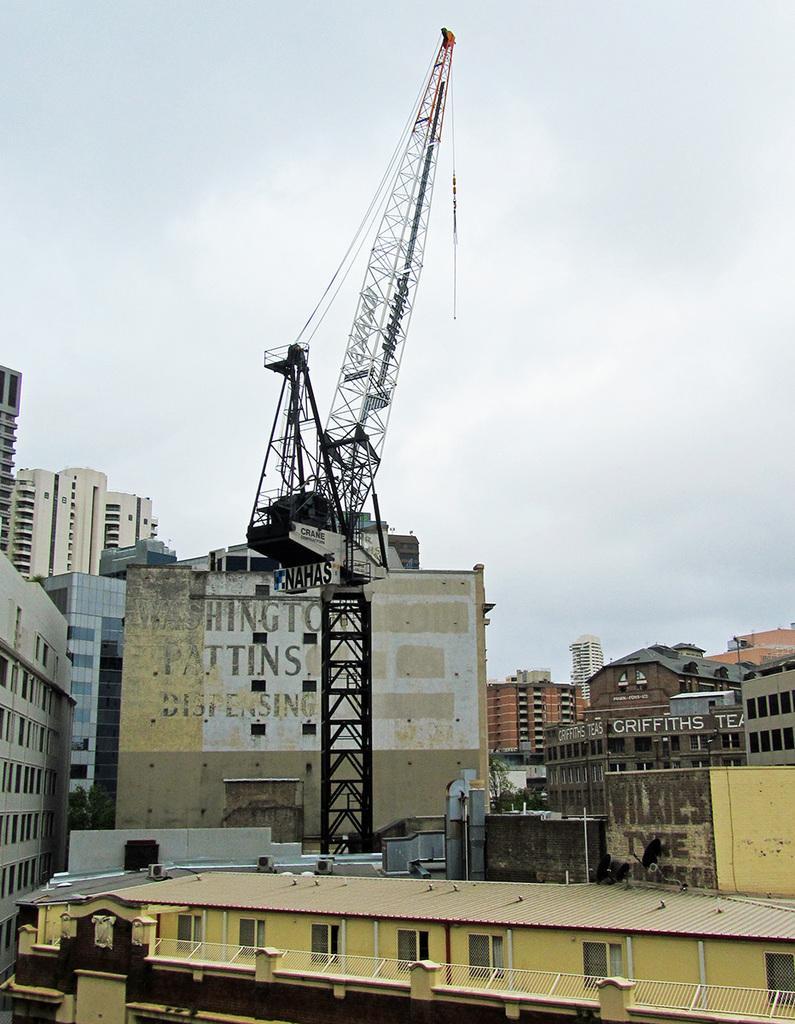Describe this image in one or two sentences. In this image, I can see the buildings and a tower crane. In the background, there is the sky. 